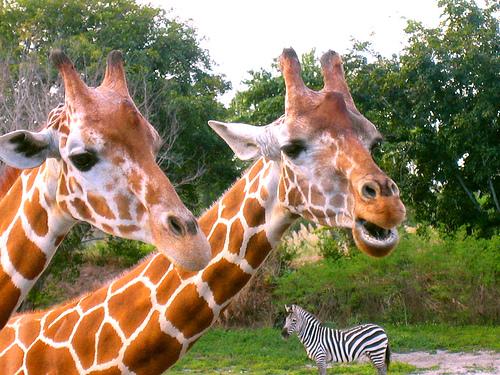Can you ride a giraffe?
Keep it brief. No. How many different animals are present here?
Answer briefly. 2. How many zebras?
Concise answer only. 1. 